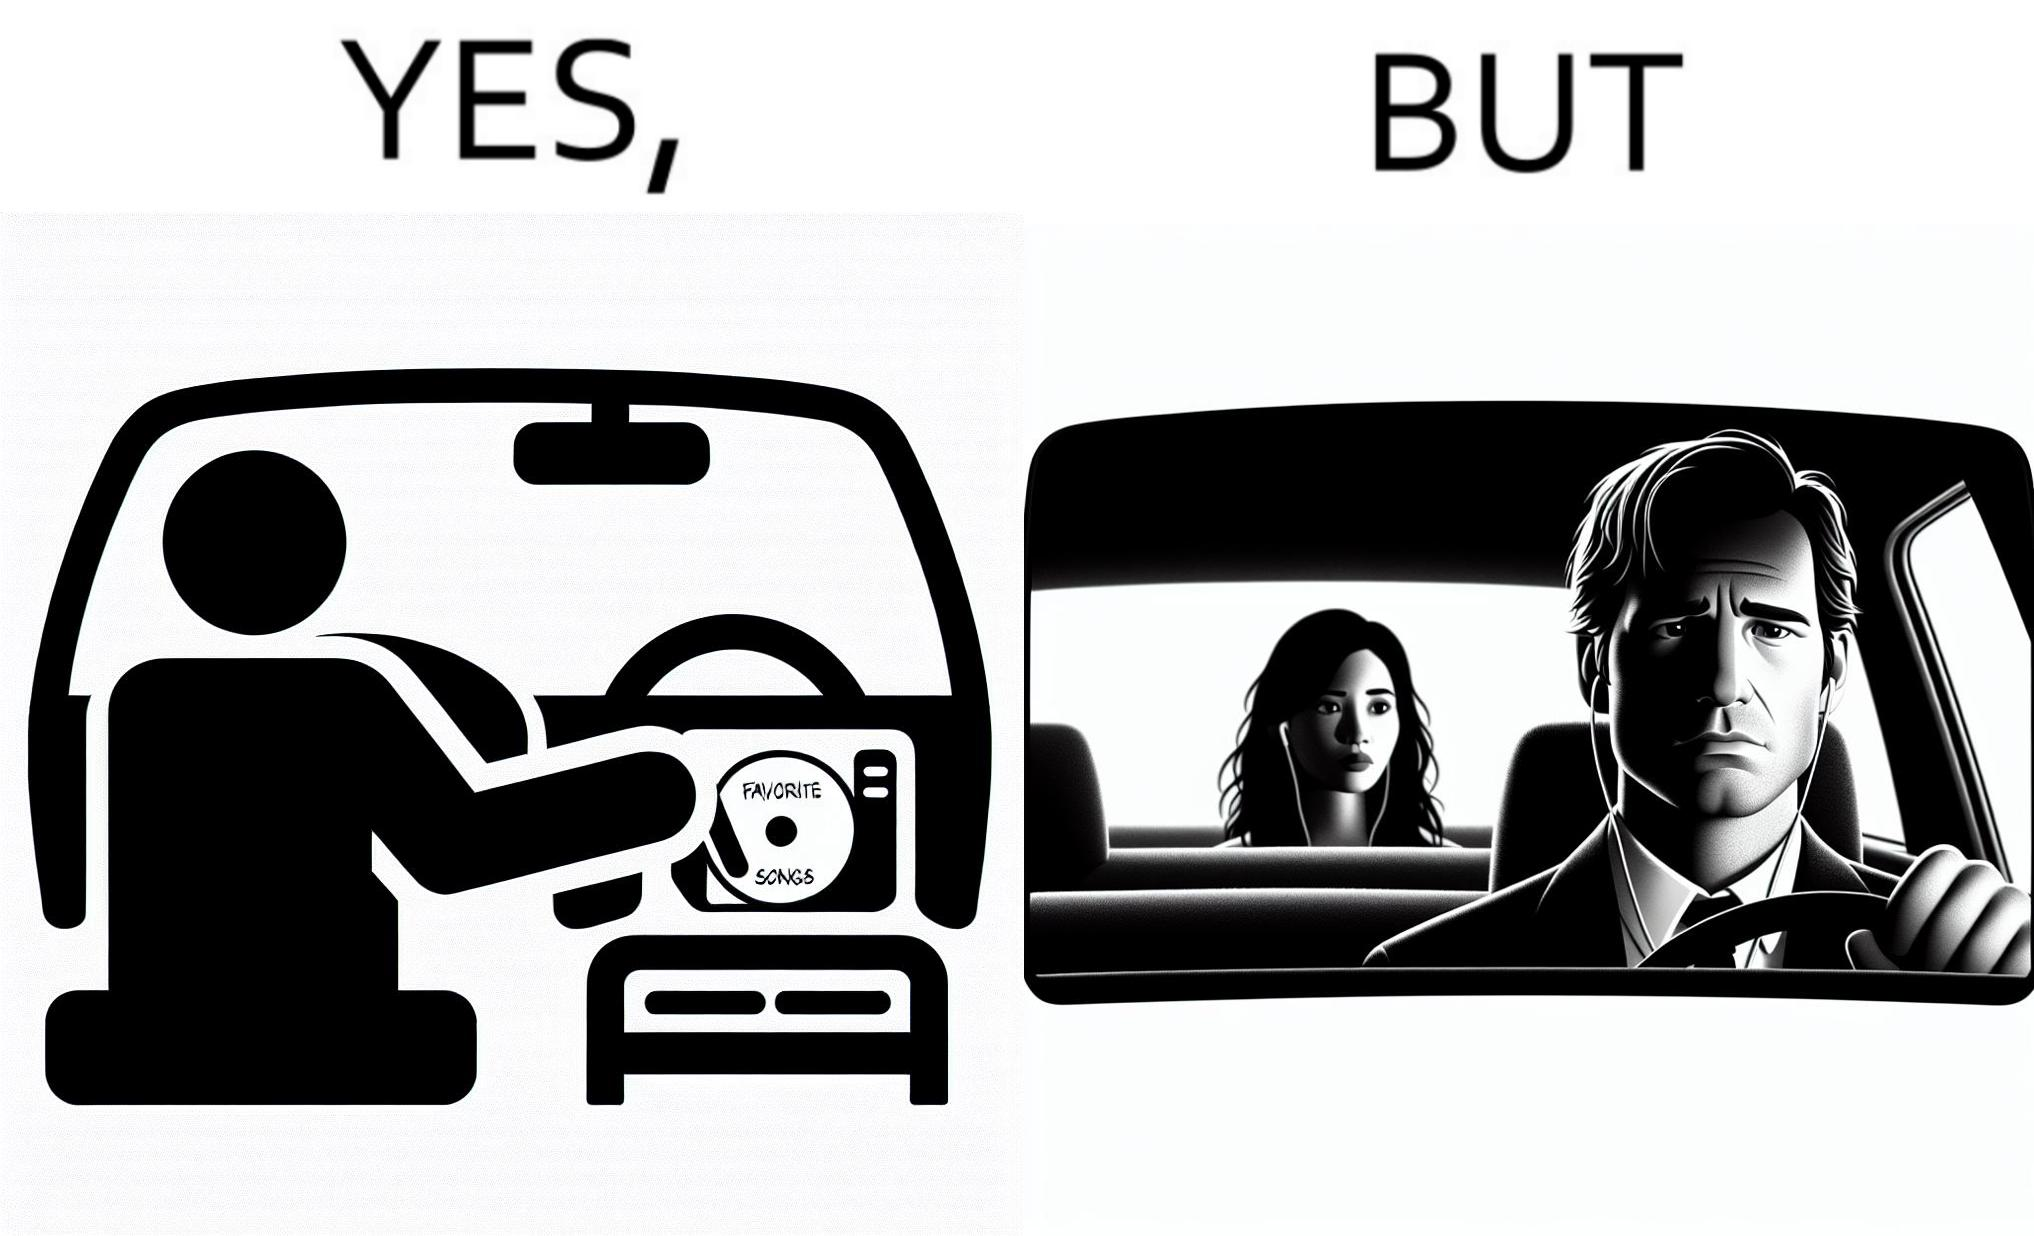What is shown in this image? The image is funny, as the driver of the car inserts a CD named "Favorite Songs" into the CD player for the passenger, but the driver is sad on seeing the passenger in the back seat listening to something else on earphones instead. 